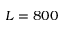Convert formula to latex. <formula><loc_0><loc_0><loc_500><loc_500>L = 8 0 0</formula> 